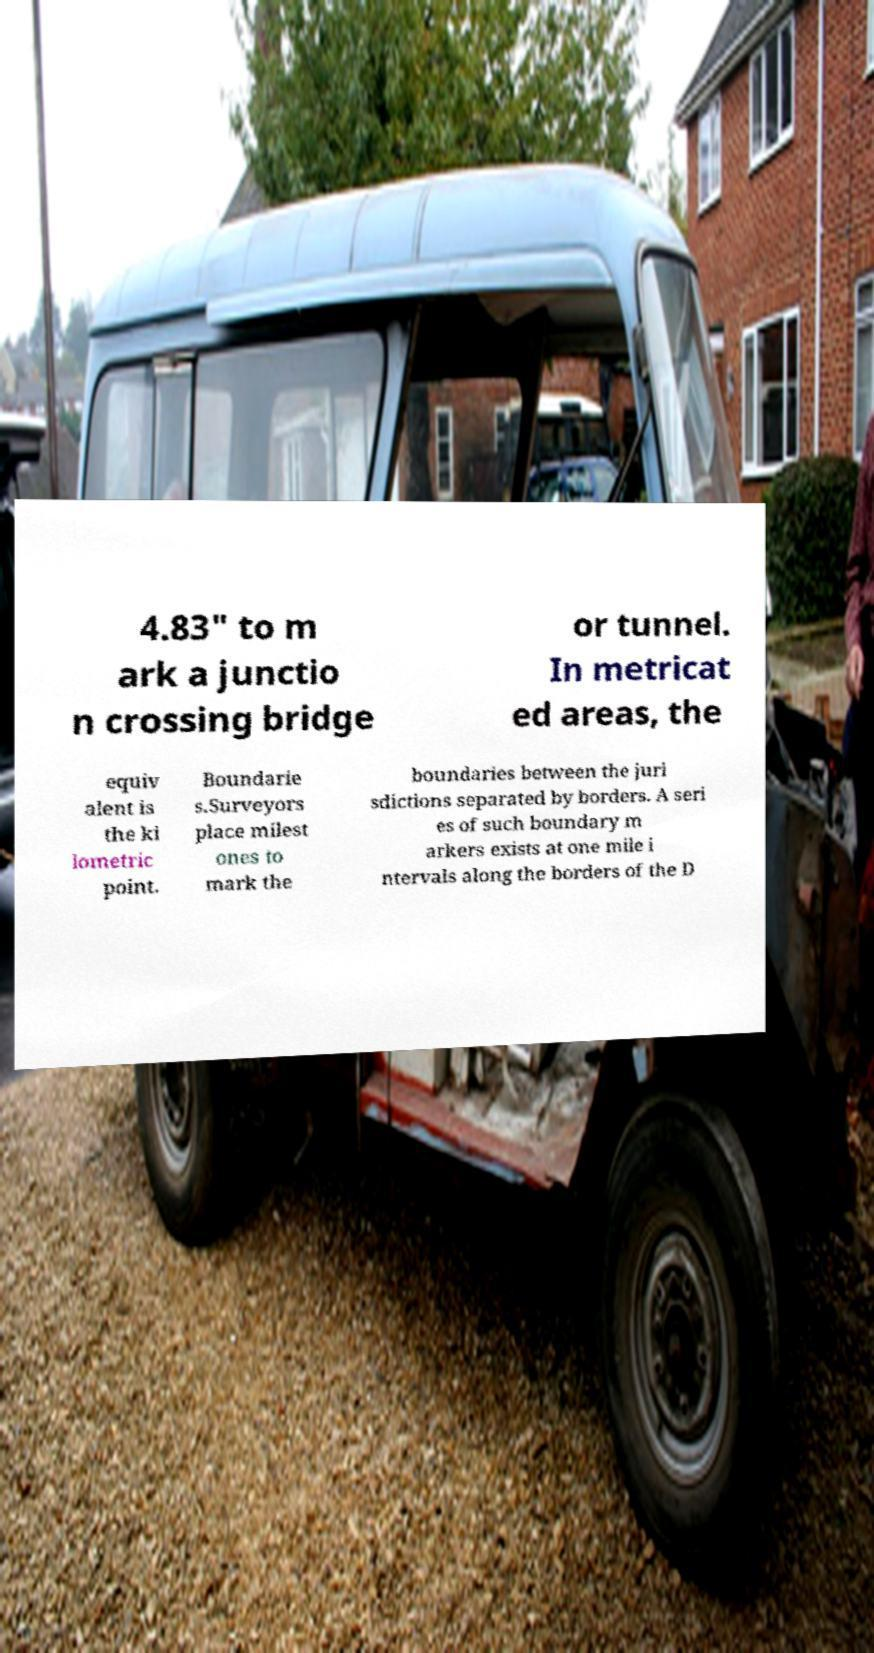I need the written content from this picture converted into text. Can you do that? 4.83" to m ark a junctio n crossing bridge or tunnel. In metricat ed areas, the equiv alent is the ki lometric point. Boundarie s.Surveyors place milest ones to mark the boundaries between the juri sdictions separated by borders. A seri es of such boundary m arkers exists at one mile i ntervals along the borders of the D 